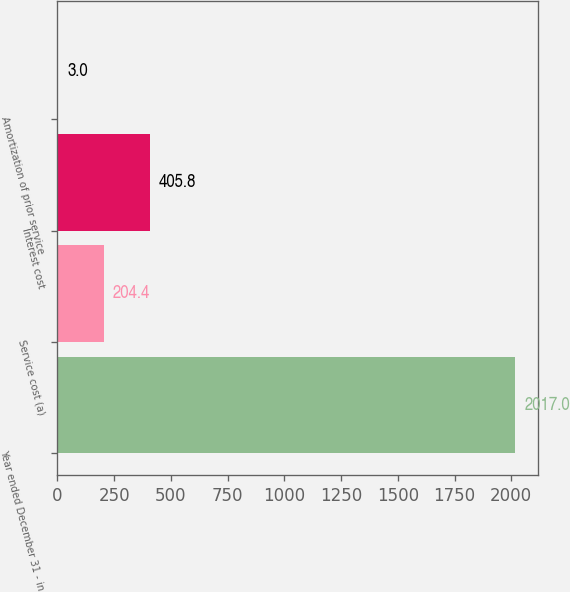Convert chart to OTSL. <chart><loc_0><loc_0><loc_500><loc_500><bar_chart><fcel>Year ended December 31 - in<fcel>Service cost (a)<fcel>Interest cost<fcel>Amortization of prior service<nl><fcel>2017<fcel>204.4<fcel>405.8<fcel>3<nl></chart> 